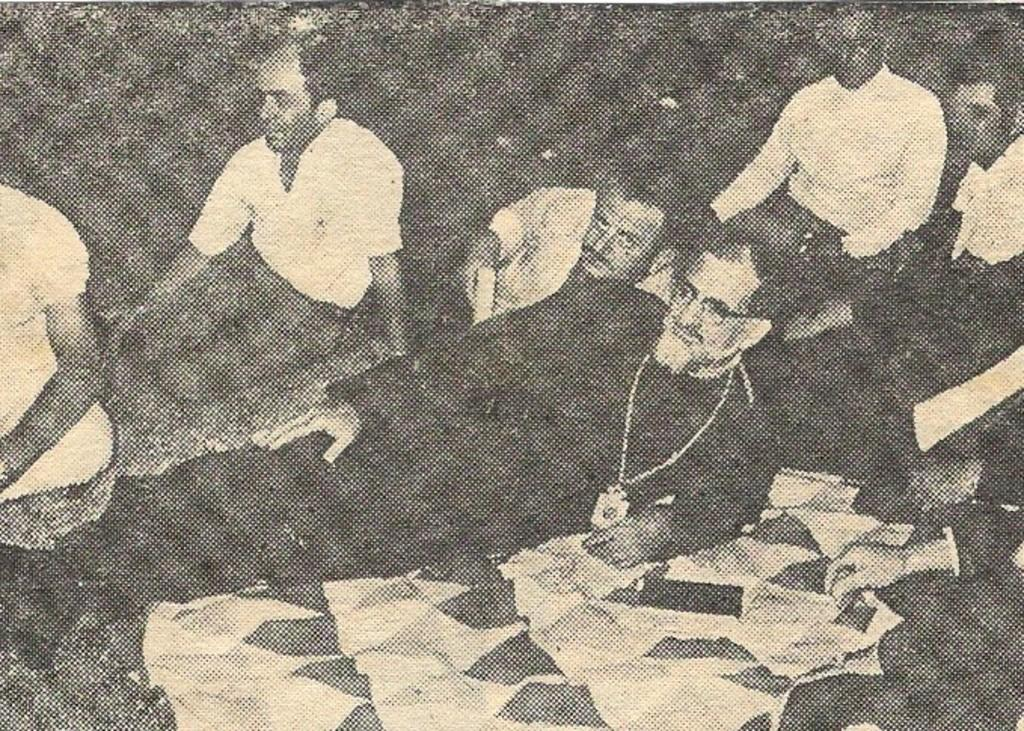What is the color scheme of the image? The image is black and white. What is the main subject of the image? There is a person lying on the ground in the image. Are there any other people visible in the image? Yes, there are a few people behind the person lying on the ground, from left to right. What type of grass is growing on the roof in the image? There is no grass or roof present in the image; it is a black and white image featuring a person lying on the ground with a few people behind them. 